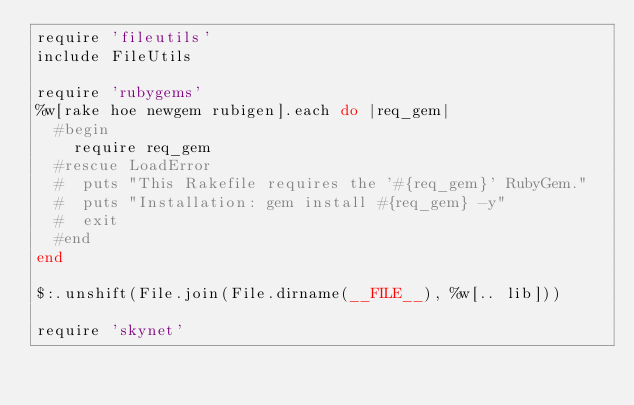<code> <loc_0><loc_0><loc_500><loc_500><_Ruby_>require 'fileutils'
include FileUtils

require 'rubygems'
%w[rake hoe newgem rubigen].each do |req_gem|
  #begin
    require req_gem
  #rescue LoadError
  #  puts "This Rakefile requires the '#{req_gem}' RubyGem."
  #  puts "Installation: gem install #{req_gem} -y"
  #  exit
  #end
end

$:.unshift(File.join(File.dirname(__FILE__), %w[.. lib]))

require 'skynet'</code> 